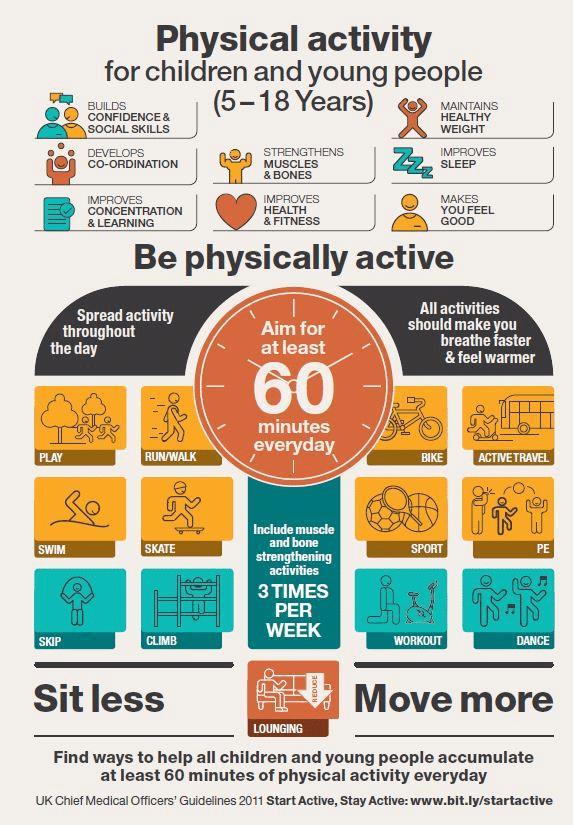How many activities mentioned in this infographic?
Answer the question with a short phrase. 12 How many positive aspects of physical activity mentioned in this infographic? 8 